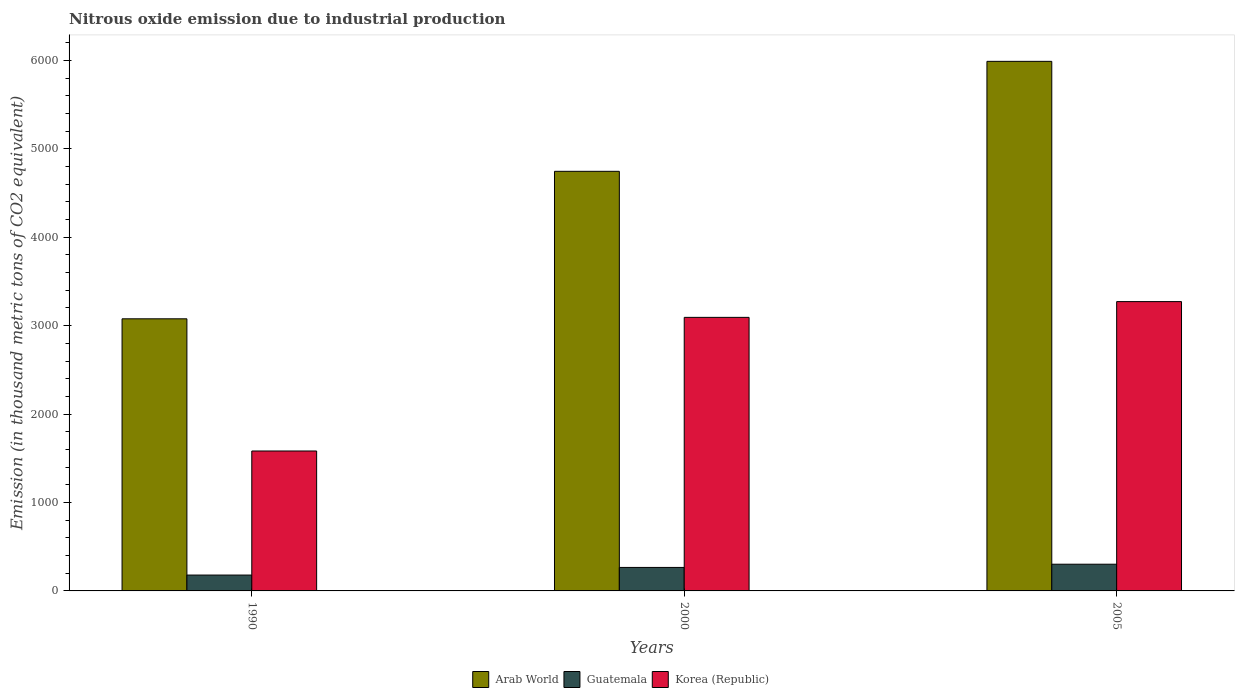How many different coloured bars are there?
Your answer should be compact. 3. How many groups of bars are there?
Give a very brief answer. 3. Are the number of bars per tick equal to the number of legend labels?
Make the answer very short. Yes. Are the number of bars on each tick of the X-axis equal?
Provide a succinct answer. Yes. How many bars are there on the 2nd tick from the left?
Provide a succinct answer. 3. What is the amount of nitrous oxide emitted in Korea (Republic) in 1990?
Provide a succinct answer. 1582.6. Across all years, what is the maximum amount of nitrous oxide emitted in Guatemala?
Offer a terse response. 302.1. Across all years, what is the minimum amount of nitrous oxide emitted in Guatemala?
Offer a terse response. 179.5. In which year was the amount of nitrous oxide emitted in Guatemala minimum?
Your answer should be very brief. 1990. What is the total amount of nitrous oxide emitted in Arab World in the graph?
Keep it short and to the point. 1.38e+04. What is the difference between the amount of nitrous oxide emitted in Arab World in 1990 and that in 2000?
Your answer should be very brief. -1668.1. What is the difference between the amount of nitrous oxide emitted in Korea (Republic) in 2000 and the amount of nitrous oxide emitted in Arab World in 1990?
Make the answer very short. 16.3. What is the average amount of nitrous oxide emitted in Guatemala per year?
Provide a short and direct response. 249.07. In the year 2000, what is the difference between the amount of nitrous oxide emitted in Korea (Republic) and amount of nitrous oxide emitted in Arab World?
Your answer should be compact. -1651.8. What is the ratio of the amount of nitrous oxide emitted in Korea (Republic) in 2000 to that in 2005?
Keep it short and to the point. 0.95. What is the difference between the highest and the second highest amount of nitrous oxide emitted in Korea (Republic)?
Provide a short and direct response. 178.3. What is the difference between the highest and the lowest amount of nitrous oxide emitted in Korea (Republic)?
Provide a succinct answer. 1689.4. What does the 2nd bar from the left in 2005 represents?
Ensure brevity in your answer.  Guatemala. What does the 2nd bar from the right in 2000 represents?
Your answer should be very brief. Guatemala. Are the values on the major ticks of Y-axis written in scientific E-notation?
Ensure brevity in your answer.  No. Does the graph contain grids?
Your answer should be compact. No. How many legend labels are there?
Your answer should be very brief. 3. What is the title of the graph?
Your answer should be compact. Nitrous oxide emission due to industrial production. Does "Europe(developing only)" appear as one of the legend labels in the graph?
Give a very brief answer. No. What is the label or title of the Y-axis?
Offer a very short reply. Emission (in thousand metric tons of CO2 equivalent). What is the Emission (in thousand metric tons of CO2 equivalent) of Arab World in 1990?
Your response must be concise. 3077.4. What is the Emission (in thousand metric tons of CO2 equivalent) in Guatemala in 1990?
Ensure brevity in your answer.  179.5. What is the Emission (in thousand metric tons of CO2 equivalent) in Korea (Republic) in 1990?
Provide a short and direct response. 1582.6. What is the Emission (in thousand metric tons of CO2 equivalent) in Arab World in 2000?
Make the answer very short. 4745.5. What is the Emission (in thousand metric tons of CO2 equivalent) in Guatemala in 2000?
Provide a short and direct response. 265.6. What is the Emission (in thousand metric tons of CO2 equivalent) in Korea (Republic) in 2000?
Make the answer very short. 3093.7. What is the Emission (in thousand metric tons of CO2 equivalent) in Arab World in 2005?
Give a very brief answer. 5989.1. What is the Emission (in thousand metric tons of CO2 equivalent) in Guatemala in 2005?
Provide a succinct answer. 302.1. What is the Emission (in thousand metric tons of CO2 equivalent) in Korea (Republic) in 2005?
Your answer should be compact. 3272. Across all years, what is the maximum Emission (in thousand metric tons of CO2 equivalent) of Arab World?
Your response must be concise. 5989.1. Across all years, what is the maximum Emission (in thousand metric tons of CO2 equivalent) in Guatemala?
Your answer should be very brief. 302.1. Across all years, what is the maximum Emission (in thousand metric tons of CO2 equivalent) of Korea (Republic)?
Offer a terse response. 3272. Across all years, what is the minimum Emission (in thousand metric tons of CO2 equivalent) in Arab World?
Offer a very short reply. 3077.4. Across all years, what is the minimum Emission (in thousand metric tons of CO2 equivalent) of Guatemala?
Offer a very short reply. 179.5. Across all years, what is the minimum Emission (in thousand metric tons of CO2 equivalent) of Korea (Republic)?
Ensure brevity in your answer.  1582.6. What is the total Emission (in thousand metric tons of CO2 equivalent) in Arab World in the graph?
Your answer should be very brief. 1.38e+04. What is the total Emission (in thousand metric tons of CO2 equivalent) in Guatemala in the graph?
Your answer should be compact. 747.2. What is the total Emission (in thousand metric tons of CO2 equivalent) in Korea (Republic) in the graph?
Provide a succinct answer. 7948.3. What is the difference between the Emission (in thousand metric tons of CO2 equivalent) of Arab World in 1990 and that in 2000?
Your answer should be compact. -1668.1. What is the difference between the Emission (in thousand metric tons of CO2 equivalent) of Guatemala in 1990 and that in 2000?
Your response must be concise. -86.1. What is the difference between the Emission (in thousand metric tons of CO2 equivalent) of Korea (Republic) in 1990 and that in 2000?
Make the answer very short. -1511.1. What is the difference between the Emission (in thousand metric tons of CO2 equivalent) of Arab World in 1990 and that in 2005?
Give a very brief answer. -2911.7. What is the difference between the Emission (in thousand metric tons of CO2 equivalent) of Guatemala in 1990 and that in 2005?
Your response must be concise. -122.6. What is the difference between the Emission (in thousand metric tons of CO2 equivalent) in Korea (Republic) in 1990 and that in 2005?
Your answer should be compact. -1689.4. What is the difference between the Emission (in thousand metric tons of CO2 equivalent) in Arab World in 2000 and that in 2005?
Make the answer very short. -1243.6. What is the difference between the Emission (in thousand metric tons of CO2 equivalent) in Guatemala in 2000 and that in 2005?
Provide a short and direct response. -36.5. What is the difference between the Emission (in thousand metric tons of CO2 equivalent) of Korea (Republic) in 2000 and that in 2005?
Give a very brief answer. -178.3. What is the difference between the Emission (in thousand metric tons of CO2 equivalent) of Arab World in 1990 and the Emission (in thousand metric tons of CO2 equivalent) of Guatemala in 2000?
Your answer should be compact. 2811.8. What is the difference between the Emission (in thousand metric tons of CO2 equivalent) in Arab World in 1990 and the Emission (in thousand metric tons of CO2 equivalent) in Korea (Republic) in 2000?
Your response must be concise. -16.3. What is the difference between the Emission (in thousand metric tons of CO2 equivalent) in Guatemala in 1990 and the Emission (in thousand metric tons of CO2 equivalent) in Korea (Republic) in 2000?
Give a very brief answer. -2914.2. What is the difference between the Emission (in thousand metric tons of CO2 equivalent) in Arab World in 1990 and the Emission (in thousand metric tons of CO2 equivalent) in Guatemala in 2005?
Your answer should be compact. 2775.3. What is the difference between the Emission (in thousand metric tons of CO2 equivalent) in Arab World in 1990 and the Emission (in thousand metric tons of CO2 equivalent) in Korea (Republic) in 2005?
Offer a very short reply. -194.6. What is the difference between the Emission (in thousand metric tons of CO2 equivalent) in Guatemala in 1990 and the Emission (in thousand metric tons of CO2 equivalent) in Korea (Republic) in 2005?
Your response must be concise. -3092.5. What is the difference between the Emission (in thousand metric tons of CO2 equivalent) of Arab World in 2000 and the Emission (in thousand metric tons of CO2 equivalent) of Guatemala in 2005?
Your answer should be very brief. 4443.4. What is the difference between the Emission (in thousand metric tons of CO2 equivalent) of Arab World in 2000 and the Emission (in thousand metric tons of CO2 equivalent) of Korea (Republic) in 2005?
Offer a very short reply. 1473.5. What is the difference between the Emission (in thousand metric tons of CO2 equivalent) in Guatemala in 2000 and the Emission (in thousand metric tons of CO2 equivalent) in Korea (Republic) in 2005?
Your answer should be very brief. -3006.4. What is the average Emission (in thousand metric tons of CO2 equivalent) of Arab World per year?
Provide a succinct answer. 4604. What is the average Emission (in thousand metric tons of CO2 equivalent) of Guatemala per year?
Offer a very short reply. 249.07. What is the average Emission (in thousand metric tons of CO2 equivalent) of Korea (Republic) per year?
Your answer should be very brief. 2649.43. In the year 1990, what is the difference between the Emission (in thousand metric tons of CO2 equivalent) in Arab World and Emission (in thousand metric tons of CO2 equivalent) in Guatemala?
Your answer should be very brief. 2897.9. In the year 1990, what is the difference between the Emission (in thousand metric tons of CO2 equivalent) of Arab World and Emission (in thousand metric tons of CO2 equivalent) of Korea (Republic)?
Your answer should be very brief. 1494.8. In the year 1990, what is the difference between the Emission (in thousand metric tons of CO2 equivalent) in Guatemala and Emission (in thousand metric tons of CO2 equivalent) in Korea (Republic)?
Provide a succinct answer. -1403.1. In the year 2000, what is the difference between the Emission (in thousand metric tons of CO2 equivalent) in Arab World and Emission (in thousand metric tons of CO2 equivalent) in Guatemala?
Offer a terse response. 4479.9. In the year 2000, what is the difference between the Emission (in thousand metric tons of CO2 equivalent) of Arab World and Emission (in thousand metric tons of CO2 equivalent) of Korea (Republic)?
Your answer should be compact. 1651.8. In the year 2000, what is the difference between the Emission (in thousand metric tons of CO2 equivalent) in Guatemala and Emission (in thousand metric tons of CO2 equivalent) in Korea (Republic)?
Make the answer very short. -2828.1. In the year 2005, what is the difference between the Emission (in thousand metric tons of CO2 equivalent) in Arab World and Emission (in thousand metric tons of CO2 equivalent) in Guatemala?
Provide a succinct answer. 5687. In the year 2005, what is the difference between the Emission (in thousand metric tons of CO2 equivalent) in Arab World and Emission (in thousand metric tons of CO2 equivalent) in Korea (Republic)?
Give a very brief answer. 2717.1. In the year 2005, what is the difference between the Emission (in thousand metric tons of CO2 equivalent) in Guatemala and Emission (in thousand metric tons of CO2 equivalent) in Korea (Republic)?
Offer a terse response. -2969.9. What is the ratio of the Emission (in thousand metric tons of CO2 equivalent) in Arab World in 1990 to that in 2000?
Keep it short and to the point. 0.65. What is the ratio of the Emission (in thousand metric tons of CO2 equivalent) of Guatemala in 1990 to that in 2000?
Your response must be concise. 0.68. What is the ratio of the Emission (in thousand metric tons of CO2 equivalent) in Korea (Republic) in 1990 to that in 2000?
Your response must be concise. 0.51. What is the ratio of the Emission (in thousand metric tons of CO2 equivalent) of Arab World in 1990 to that in 2005?
Offer a terse response. 0.51. What is the ratio of the Emission (in thousand metric tons of CO2 equivalent) of Guatemala in 1990 to that in 2005?
Your answer should be very brief. 0.59. What is the ratio of the Emission (in thousand metric tons of CO2 equivalent) in Korea (Republic) in 1990 to that in 2005?
Provide a succinct answer. 0.48. What is the ratio of the Emission (in thousand metric tons of CO2 equivalent) of Arab World in 2000 to that in 2005?
Give a very brief answer. 0.79. What is the ratio of the Emission (in thousand metric tons of CO2 equivalent) in Guatemala in 2000 to that in 2005?
Offer a terse response. 0.88. What is the ratio of the Emission (in thousand metric tons of CO2 equivalent) of Korea (Republic) in 2000 to that in 2005?
Ensure brevity in your answer.  0.95. What is the difference between the highest and the second highest Emission (in thousand metric tons of CO2 equivalent) of Arab World?
Give a very brief answer. 1243.6. What is the difference between the highest and the second highest Emission (in thousand metric tons of CO2 equivalent) of Guatemala?
Your answer should be very brief. 36.5. What is the difference between the highest and the second highest Emission (in thousand metric tons of CO2 equivalent) in Korea (Republic)?
Make the answer very short. 178.3. What is the difference between the highest and the lowest Emission (in thousand metric tons of CO2 equivalent) of Arab World?
Ensure brevity in your answer.  2911.7. What is the difference between the highest and the lowest Emission (in thousand metric tons of CO2 equivalent) of Guatemala?
Provide a short and direct response. 122.6. What is the difference between the highest and the lowest Emission (in thousand metric tons of CO2 equivalent) in Korea (Republic)?
Your answer should be compact. 1689.4. 